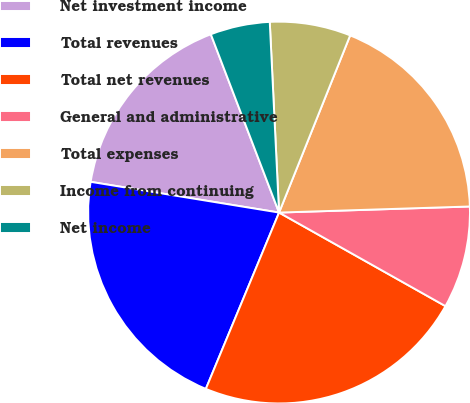<chart> <loc_0><loc_0><loc_500><loc_500><pie_chart><fcel>Net investment income<fcel>Total revenues<fcel>Total net revenues<fcel>General and administrative<fcel>Total expenses<fcel>Income from continuing<fcel>Net income<nl><fcel>16.61%<fcel>21.31%<fcel>23.11%<fcel>8.66%<fcel>18.42%<fcel>6.85%<fcel>5.04%<nl></chart> 